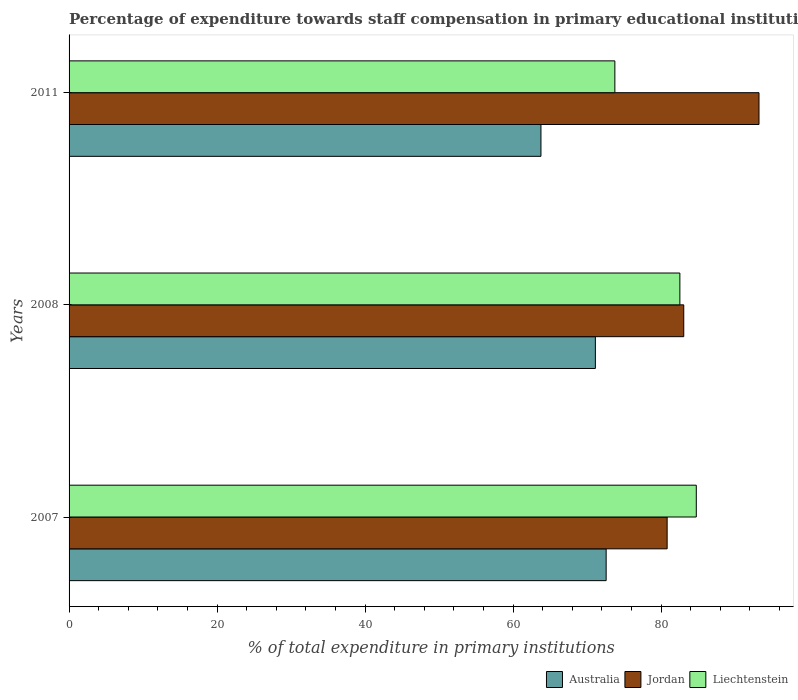How many groups of bars are there?
Offer a terse response. 3. Are the number of bars per tick equal to the number of legend labels?
Offer a very short reply. Yes. Are the number of bars on each tick of the Y-axis equal?
Your answer should be very brief. Yes. What is the label of the 2nd group of bars from the top?
Your response must be concise. 2008. In how many cases, is the number of bars for a given year not equal to the number of legend labels?
Your response must be concise. 0. What is the percentage of expenditure towards staff compensation in Jordan in 2008?
Keep it short and to the point. 83.08. Across all years, what is the maximum percentage of expenditure towards staff compensation in Jordan?
Offer a very short reply. 93.24. Across all years, what is the minimum percentage of expenditure towards staff compensation in Australia?
Provide a succinct answer. 63.78. What is the total percentage of expenditure towards staff compensation in Australia in the graph?
Offer a very short reply. 207.49. What is the difference between the percentage of expenditure towards staff compensation in Australia in 2008 and that in 2011?
Provide a succinct answer. 7.35. What is the difference between the percentage of expenditure towards staff compensation in Australia in 2008 and the percentage of expenditure towards staff compensation in Liechtenstein in 2007?
Give a very brief answer. -13.64. What is the average percentage of expenditure towards staff compensation in Liechtenstein per year?
Offer a terse response. 80.36. In the year 2011, what is the difference between the percentage of expenditure towards staff compensation in Jordan and percentage of expenditure towards staff compensation in Australia?
Provide a succinct answer. 29.47. What is the ratio of the percentage of expenditure towards staff compensation in Jordan in 2008 to that in 2011?
Make the answer very short. 0.89. Is the percentage of expenditure towards staff compensation in Jordan in 2008 less than that in 2011?
Ensure brevity in your answer.  Yes. Is the difference between the percentage of expenditure towards staff compensation in Jordan in 2007 and 2011 greater than the difference between the percentage of expenditure towards staff compensation in Australia in 2007 and 2011?
Your answer should be compact. No. What is the difference between the highest and the second highest percentage of expenditure towards staff compensation in Jordan?
Offer a terse response. 10.17. What is the difference between the highest and the lowest percentage of expenditure towards staff compensation in Australia?
Your response must be concise. 8.81. In how many years, is the percentage of expenditure towards staff compensation in Australia greater than the average percentage of expenditure towards staff compensation in Australia taken over all years?
Your response must be concise. 2. What does the 1st bar from the bottom in 2008 represents?
Your answer should be very brief. Australia. Are all the bars in the graph horizontal?
Keep it short and to the point. Yes. How many years are there in the graph?
Your answer should be compact. 3. Are the values on the major ticks of X-axis written in scientific E-notation?
Ensure brevity in your answer.  No. Does the graph contain grids?
Make the answer very short. No. How many legend labels are there?
Offer a terse response. 3. How are the legend labels stacked?
Make the answer very short. Horizontal. What is the title of the graph?
Make the answer very short. Percentage of expenditure towards staff compensation in primary educational institutions. Does "Tunisia" appear as one of the legend labels in the graph?
Ensure brevity in your answer.  No. What is the label or title of the X-axis?
Your answer should be compact. % of total expenditure in primary institutions. What is the label or title of the Y-axis?
Your answer should be compact. Years. What is the % of total expenditure in primary institutions in Australia in 2007?
Your answer should be compact. 72.59. What is the % of total expenditure in primary institutions of Jordan in 2007?
Your response must be concise. 80.83. What is the % of total expenditure in primary institutions in Liechtenstein in 2007?
Make the answer very short. 84.77. What is the % of total expenditure in primary institutions of Australia in 2008?
Your answer should be compact. 71.13. What is the % of total expenditure in primary institutions of Jordan in 2008?
Your answer should be compact. 83.08. What is the % of total expenditure in primary institutions of Liechtenstein in 2008?
Offer a very short reply. 82.55. What is the % of total expenditure in primary institutions of Australia in 2011?
Your answer should be very brief. 63.78. What is the % of total expenditure in primary institutions of Jordan in 2011?
Give a very brief answer. 93.24. What is the % of total expenditure in primary institutions in Liechtenstein in 2011?
Provide a succinct answer. 73.76. Across all years, what is the maximum % of total expenditure in primary institutions of Australia?
Give a very brief answer. 72.59. Across all years, what is the maximum % of total expenditure in primary institutions of Jordan?
Your answer should be very brief. 93.24. Across all years, what is the maximum % of total expenditure in primary institutions of Liechtenstein?
Your response must be concise. 84.77. Across all years, what is the minimum % of total expenditure in primary institutions in Australia?
Give a very brief answer. 63.78. Across all years, what is the minimum % of total expenditure in primary institutions in Jordan?
Ensure brevity in your answer.  80.83. Across all years, what is the minimum % of total expenditure in primary institutions in Liechtenstein?
Your answer should be very brief. 73.76. What is the total % of total expenditure in primary institutions of Australia in the graph?
Make the answer very short. 207.49. What is the total % of total expenditure in primary institutions of Jordan in the graph?
Your answer should be compact. 257.15. What is the total % of total expenditure in primary institutions of Liechtenstein in the graph?
Your answer should be very brief. 241.09. What is the difference between the % of total expenditure in primary institutions in Australia in 2007 and that in 2008?
Make the answer very short. 1.46. What is the difference between the % of total expenditure in primary institutions in Jordan in 2007 and that in 2008?
Offer a terse response. -2.25. What is the difference between the % of total expenditure in primary institutions in Liechtenstein in 2007 and that in 2008?
Provide a succinct answer. 2.22. What is the difference between the % of total expenditure in primary institutions of Australia in 2007 and that in 2011?
Offer a very short reply. 8.81. What is the difference between the % of total expenditure in primary institutions of Jordan in 2007 and that in 2011?
Provide a short and direct response. -12.41. What is the difference between the % of total expenditure in primary institutions of Liechtenstein in 2007 and that in 2011?
Your answer should be compact. 11.01. What is the difference between the % of total expenditure in primary institutions in Australia in 2008 and that in 2011?
Keep it short and to the point. 7.35. What is the difference between the % of total expenditure in primary institutions in Jordan in 2008 and that in 2011?
Offer a very short reply. -10.17. What is the difference between the % of total expenditure in primary institutions in Liechtenstein in 2008 and that in 2011?
Offer a terse response. 8.79. What is the difference between the % of total expenditure in primary institutions of Australia in 2007 and the % of total expenditure in primary institutions of Jordan in 2008?
Offer a terse response. -10.49. What is the difference between the % of total expenditure in primary institutions in Australia in 2007 and the % of total expenditure in primary institutions in Liechtenstein in 2008?
Your response must be concise. -9.96. What is the difference between the % of total expenditure in primary institutions of Jordan in 2007 and the % of total expenditure in primary institutions of Liechtenstein in 2008?
Make the answer very short. -1.72. What is the difference between the % of total expenditure in primary institutions in Australia in 2007 and the % of total expenditure in primary institutions in Jordan in 2011?
Your answer should be compact. -20.66. What is the difference between the % of total expenditure in primary institutions in Australia in 2007 and the % of total expenditure in primary institutions in Liechtenstein in 2011?
Your answer should be very brief. -1.18. What is the difference between the % of total expenditure in primary institutions in Jordan in 2007 and the % of total expenditure in primary institutions in Liechtenstein in 2011?
Provide a succinct answer. 7.06. What is the difference between the % of total expenditure in primary institutions in Australia in 2008 and the % of total expenditure in primary institutions in Jordan in 2011?
Give a very brief answer. -22.11. What is the difference between the % of total expenditure in primary institutions in Australia in 2008 and the % of total expenditure in primary institutions in Liechtenstein in 2011?
Your answer should be very brief. -2.63. What is the difference between the % of total expenditure in primary institutions in Jordan in 2008 and the % of total expenditure in primary institutions in Liechtenstein in 2011?
Keep it short and to the point. 9.31. What is the average % of total expenditure in primary institutions in Australia per year?
Offer a very short reply. 69.16. What is the average % of total expenditure in primary institutions in Jordan per year?
Provide a short and direct response. 85.72. What is the average % of total expenditure in primary institutions in Liechtenstein per year?
Your response must be concise. 80.36. In the year 2007, what is the difference between the % of total expenditure in primary institutions in Australia and % of total expenditure in primary institutions in Jordan?
Your response must be concise. -8.24. In the year 2007, what is the difference between the % of total expenditure in primary institutions of Australia and % of total expenditure in primary institutions of Liechtenstein?
Offer a terse response. -12.18. In the year 2007, what is the difference between the % of total expenditure in primary institutions in Jordan and % of total expenditure in primary institutions in Liechtenstein?
Provide a succinct answer. -3.94. In the year 2008, what is the difference between the % of total expenditure in primary institutions of Australia and % of total expenditure in primary institutions of Jordan?
Offer a terse response. -11.95. In the year 2008, what is the difference between the % of total expenditure in primary institutions in Australia and % of total expenditure in primary institutions in Liechtenstein?
Your answer should be compact. -11.42. In the year 2008, what is the difference between the % of total expenditure in primary institutions in Jordan and % of total expenditure in primary institutions in Liechtenstein?
Your answer should be very brief. 0.53. In the year 2011, what is the difference between the % of total expenditure in primary institutions of Australia and % of total expenditure in primary institutions of Jordan?
Your answer should be very brief. -29.47. In the year 2011, what is the difference between the % of total expenditure in primary institutions of Australia and % of total expenditure in primary institutions of Liechtenstein?
Give a very brief answer. -9.99. In the year 2011, what is the difference between the % of total expenditure in primary institutions of Jordan and % of total expenditure in primary institutions of Liechtenstein?
Give a very brief answer. 19.48. What is the ratio of the % of total expenditure in primary institutions in Australia in 2007 to that in 2008?
Make the answer very short. 1.02. What is the ratio of the % of total expenditure in primary institutions of Liechtenstein in 2007 to that in 2008?
Keep it short and to the point. 1.03. What is the ratio of the % of total expenditure in primary institutions of Australia in 2007 to that in 2011?
Your answer should be very brief. 1.14. What is the ratio of the % of total expenditure in primary institutions in Jordan in 2007 to that in 2011?
Keep it short and to the point. 0.87. What is the ratio of the % of total expenditure in primary institutions of Liechtenstein in 2007 to that in 2011?
Your answer should be very brief. 1.15. What is the ratio of the % of total expenditure in primary institutions of Australia in 2008 to that in 2011?
Offer a very short reply. 1.12. What is the ratio of the % of total expenditure in primary institutions in Jordan in 2008 to that in 2011?
Make the answer very short. 0.89. What is the ratio of the % of total expenditure in primary institutions in Liechtenstein in 2008 to that in 2011?
Your response must be concise. 1.12. What is the difference between the highest and the second highest % of total expenditure in primary institutions in Australia?
Provide a short and direct response. 1.46. What is the difference between the highest and the second highest % of total expenditure in primary institutions in Jordan?
Your answer should be compact. 10.17. What is the difference between the highest and the second highest % of total expenditure in primary institutions in Liechtenstein?
Keep it short and to the point. 2.22. What is the difference between the highest and the lowest % of total expenditure in primary institutions of Australia?
Ensure brevity in your answer.  8.81. What is the difference between the highest and the lowest % of total expenditure in primary institutions of Jordan?
Ensure brevity in your answer.  12.41. What is the difference between the highest and the lowest % of total expenditure in primary institutions of Liechtenstein?
Keep it short and to the point. 11.01. 